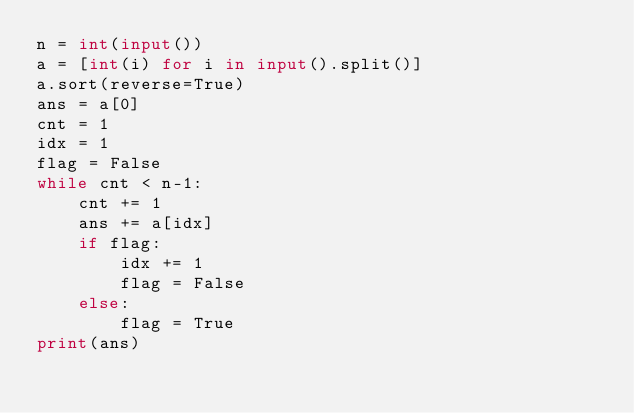Convert code to text. <code><loc_0><loc_0><loc_500><loc_500><_Python_>n = int(input())
a = [int(i) for i in input().split()]
a.sort(reverse=True)
ans = a[0]
cnt = 1
idx = 1
flag = False
while cnt < n-1:
    cnt += 1
    ans += a[idx]
    if flag:
        idx += 1
        flag = False
    else:
        flag = True
print(ans)</code> 